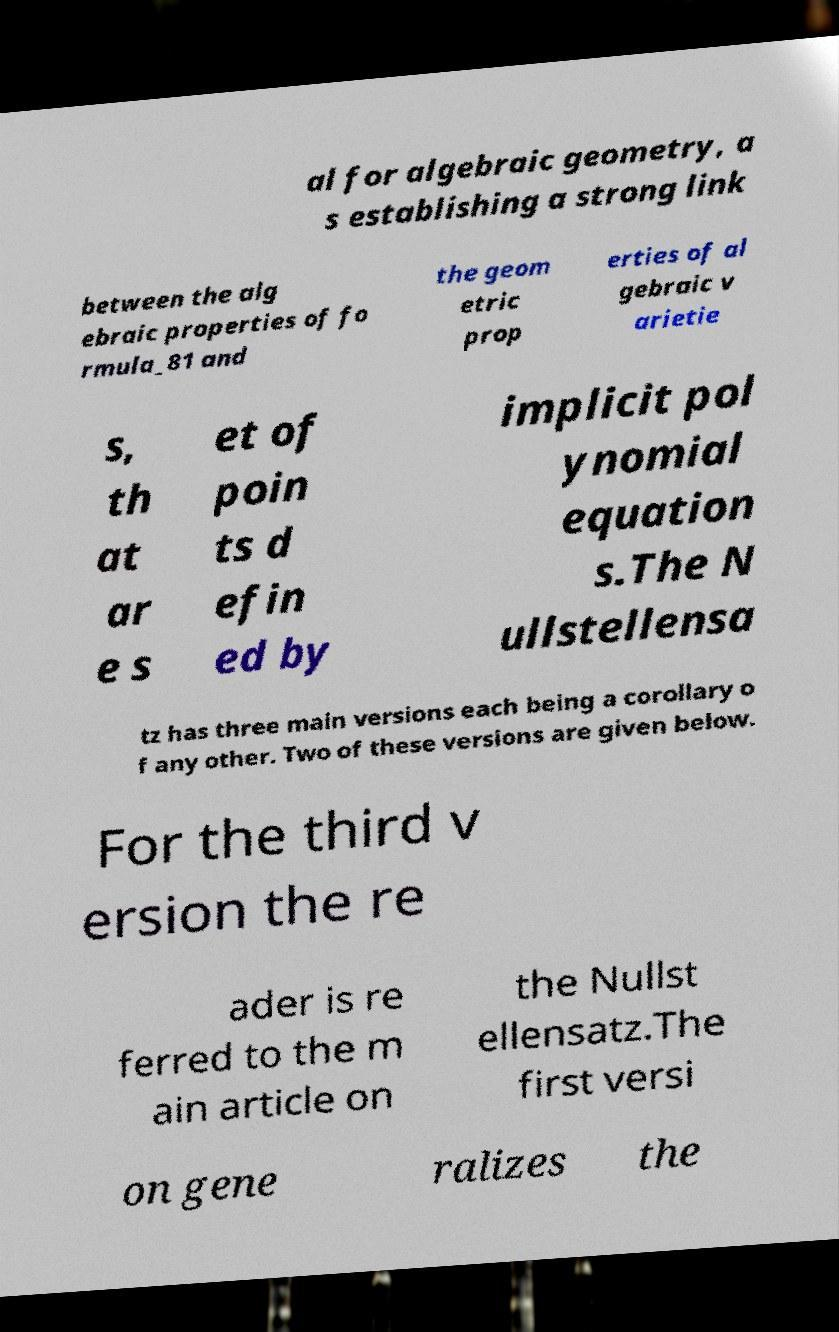I need the written content from this picture converted into text. Can you do that? al for algebraic geometry, a s establishing a strong link between the alg ebraic properties of fo rmula_81 and the geom etric prop erties of al gebraic v arietie s, th at ar e s et of poin ts d efin ed by implicit pol ynomial equation s.The N ullstellensa tz has three main versions each being a corollary o f any other. Two of these versions are given below. For the third v ersion the re ader is re ferred to the m ain article on the Nullst ellensatz.The first versi on gene ralizes the 